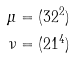<formula> <loc_0><loc_0><loc_500><loc_500>\mu & = ( 3 2 ^ { 2 } ) \\ \nu & = ( 2 1 ^ { 4 } )</formula> 